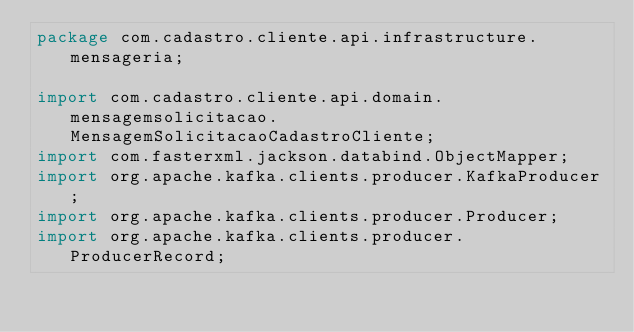<code> <loc_0><loc_0><loc_500><loc_500><_Java_>package com.cadastro.cliente.api.infrastructure.mensageria;

import com.cadastro.cliente.api.domain.mensagemsolicitacao.MensagemSolicitacaoCadastroCliente;
import com.fasterxml.jackson.databind.ObjectMapper;
import org.apache.kafka.clients.producer.KafkaProducer;
import org.apache.kafka.clients.producer.Producer;
import org.apache.kafka.clients.producer.ProducerRecord;</code> 